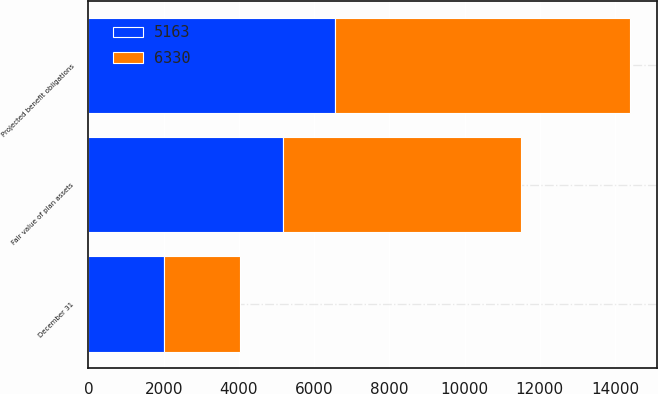Convert chart. <chart><loc_0><loc_0><loc_500><loc_500><stacked_bar_chart><ecel><fcel>December 31<fcel>Projected benefit obligations<fcel>Fair value of plan assets<nl><fcel>5163<fcel>2018<fcel>6561<fcel>5163<nl><fcel>6330<fcel>2017<fcel>7833<fcel>6330<nl></chart> 